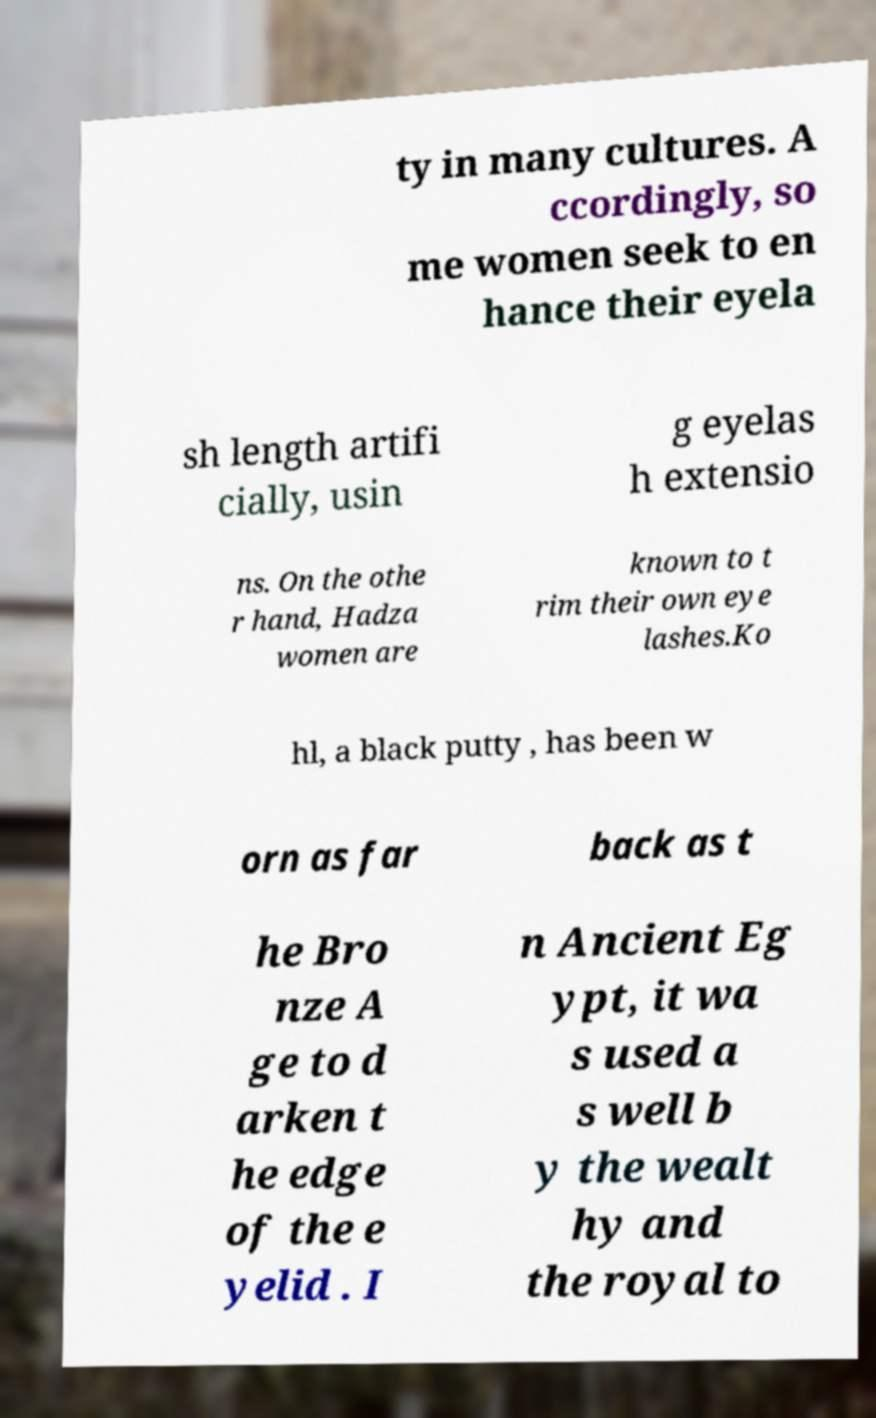I need the written content from this picture converted into text. Can you do that? ty in many cultures. A ccordingly, so me women seek to en hance their eyela sh length artifi cially, usin g eyelas h extensio ns. On the othe r hand, Hadza women are known to t rim their own eye lashes.Ko hl, a black putty , has been w orn as far back as t he Bro nze A ge to d arken t he edge of the e yelid . I n Ancient Eg ypt, it wa s used a s well b y the wealt hy and the royal to 